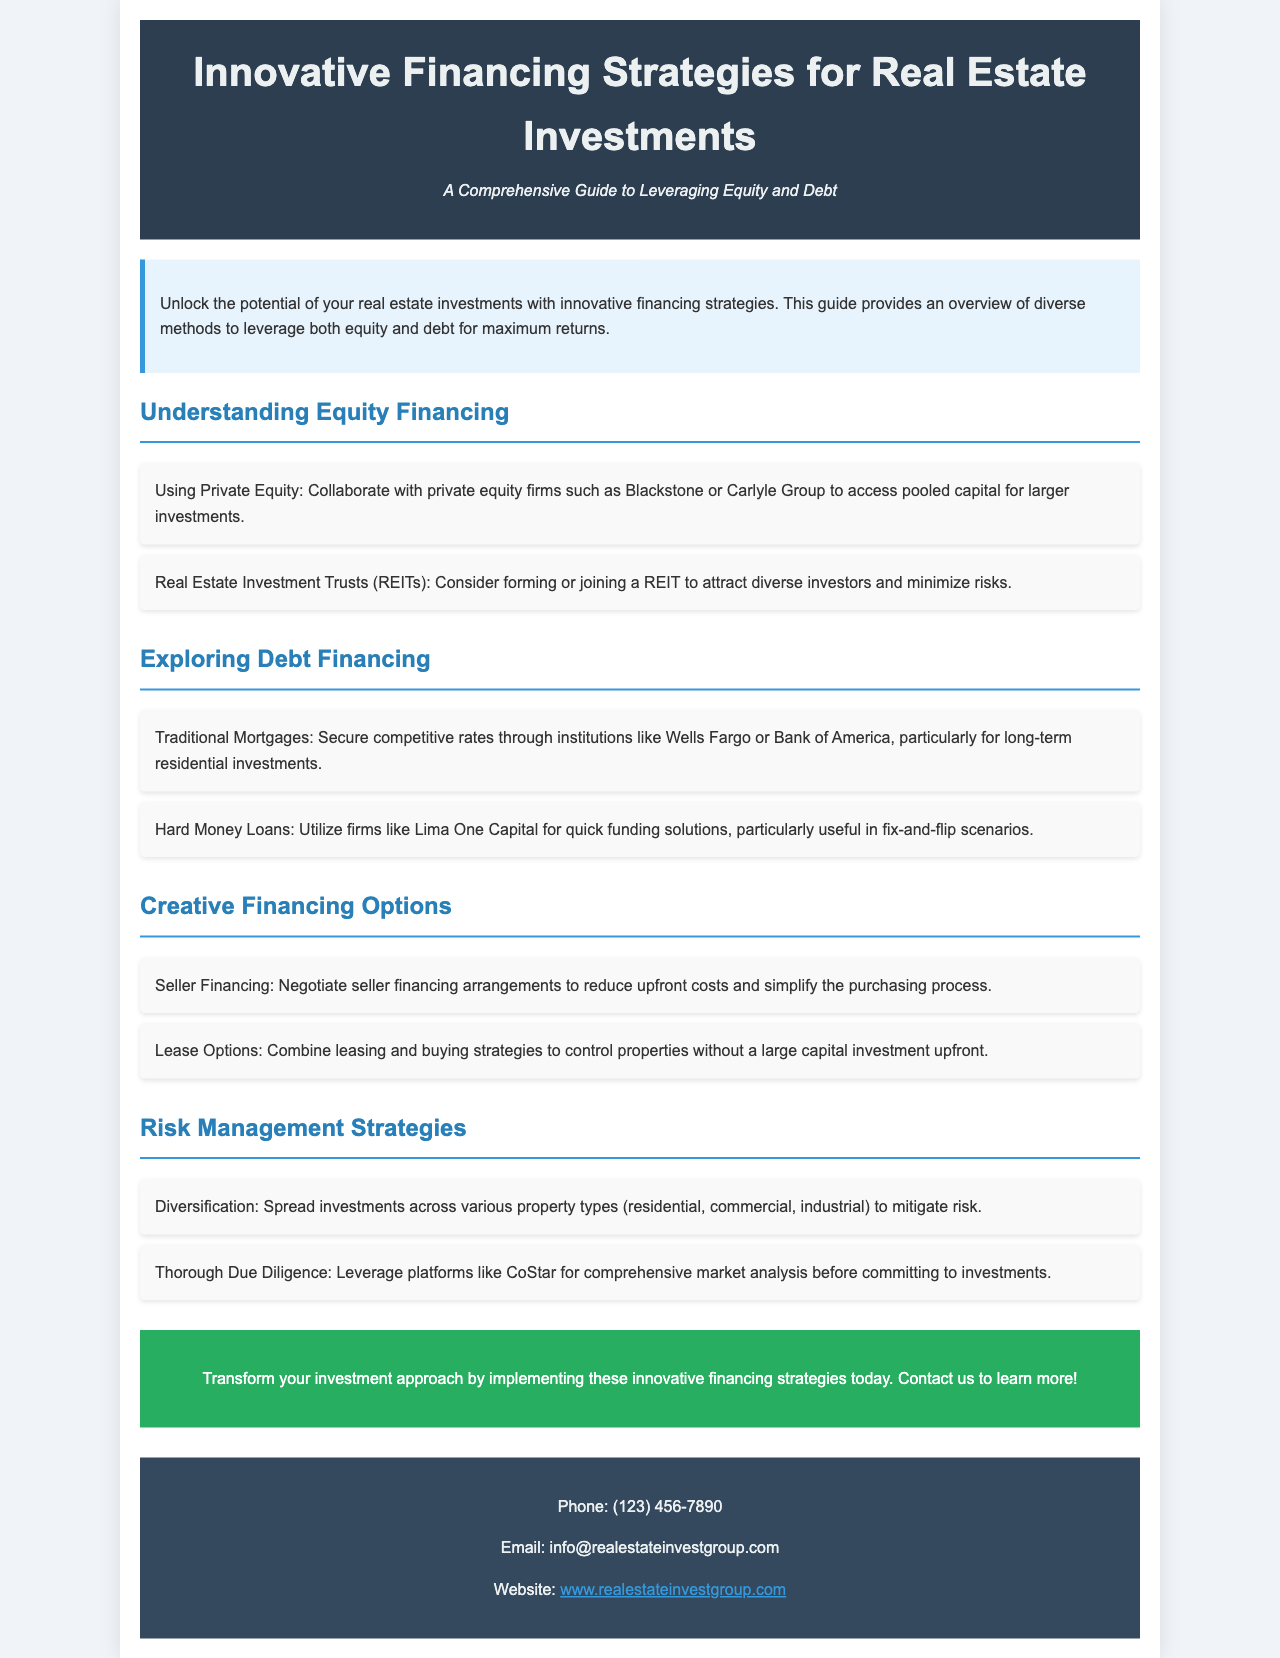what is the title of the guide? The title of the guide is prominently displayed at the top of the document, highlighting its purpose.
Answer: Innovative Financing Strategies for Real Estate Investments what are two examples of equity financing mentioned? The document lists methods for equity financing in the section titled "Understanding Equity Financing."
Answer: Private Equity, Real Estate Investment Trusts which firm is mentioned for traditional mortgages? The document specifies a couple of banks offering traditional mortgages under "Exploring Debt Financing."
Answer: Wells Fargo what type of loan is useful in fix-and-flip scenarios? The document indicates a particular financing option under the "Exploring Debt Financing" section that suits this scenario.
Answer: Hard Money Loans name one risk management strategy suggested in the brochure. The brochure presents multiple strategies for risk management in the section titled "Risk Management Strategies."
Answer: Diversification what is the phone number provided for contact? The contact information section includes a specific phone number for inquiries.
Answer: (123) 456-7890 what is the color of the header background? The header's background color is specified in the style section of the document, enhancing visibility and aesthetics.
Answer: #2c3e50 which financing method combines leasing and buying strategies? The document highlights this approach in the "Creative Financing Options" section.
Answer: Lease Options what is the email address for inquiries? The contact information section provides an email address for further communication.
Answer: info@realestateinvestgroup.com 